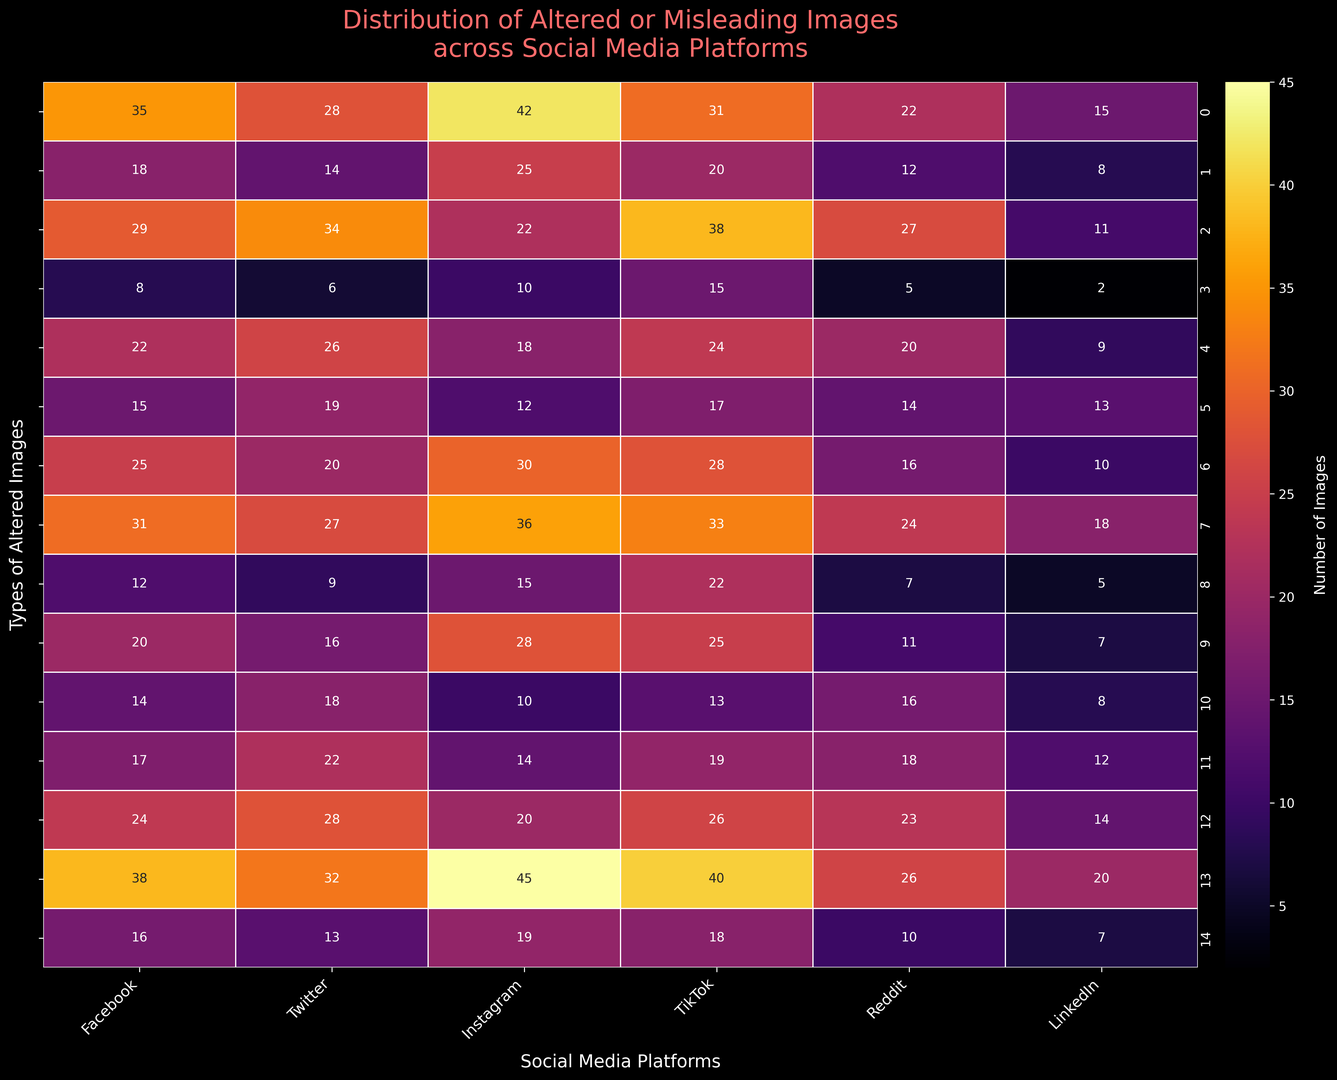Which social media platform has the highest number of photoshopped celebrity images? The platform with the highest number of photoshopped celebrity images can be identified by finding the maximum value in the row labeled "Photoshopped celebrities". This value is 28, which corresponds to Instagram.
Answer: Instagram Across all platforms, which type of altered image has the least occurrences? To determine the type of altered image with the fewest occurrences across all platforms, we need to look at the lowest summed value across each row. The "Deepfakes" category has the least total summed value: 8 + 6 + 10 + 15 + 5 + 2 = 46.
Answer: Deepfakes Which platform has an almost equal number of slightly altered images and cropped/selective framing images? By comparing the values in the rows "Slightly altered images" and "Cropped/selective framing", we find that TikTok has 31 in both categories, which is almost equal.
Answer: TikTok What is the total number of manipulated infographics on Reddit and LinkedIn combined? Sum the values in the "Manipulated infographics" row for Reddit and LinkedIn: 14 + 13 = 27.
Answer: 27 Which type of altered image has more occurrences: mislabelled images on Facebook or filtered/color-adjusted images on LinkedIn? Compare the values in the "Mislabeled images" row for Facebook (22) and the "Filtered/color-adjusted images" row for LinkedIn (20). Facebook has more mislabelled images.
Answer: Facebook What is the difference in the number of doctored screenshots between Facebook and Twitter? Subtract the value for Twitter from the value for Facebook in the "Doctored screenshots" row: 17 - 22 = -5.
Answer: -5 Which platform has the most varied distribution of altered images, considering the range between the minimum and maximum occurrences? To find the platform with the most varied distribution, calculate the range (max - min) for each platform. The platform with the highest range is Instagram, with values ranging from 10 to 45, giving a range of 35.
Answer: Instagram What is the average number of AI-generated images across all platforms? Sum the values in the "AI-generated images" row and divide by the number of platforms: (12 + 9 + 15 + 22 + 7 + 5) / 6 = 70 / 6 = 11.67.
Answer: 11.67 